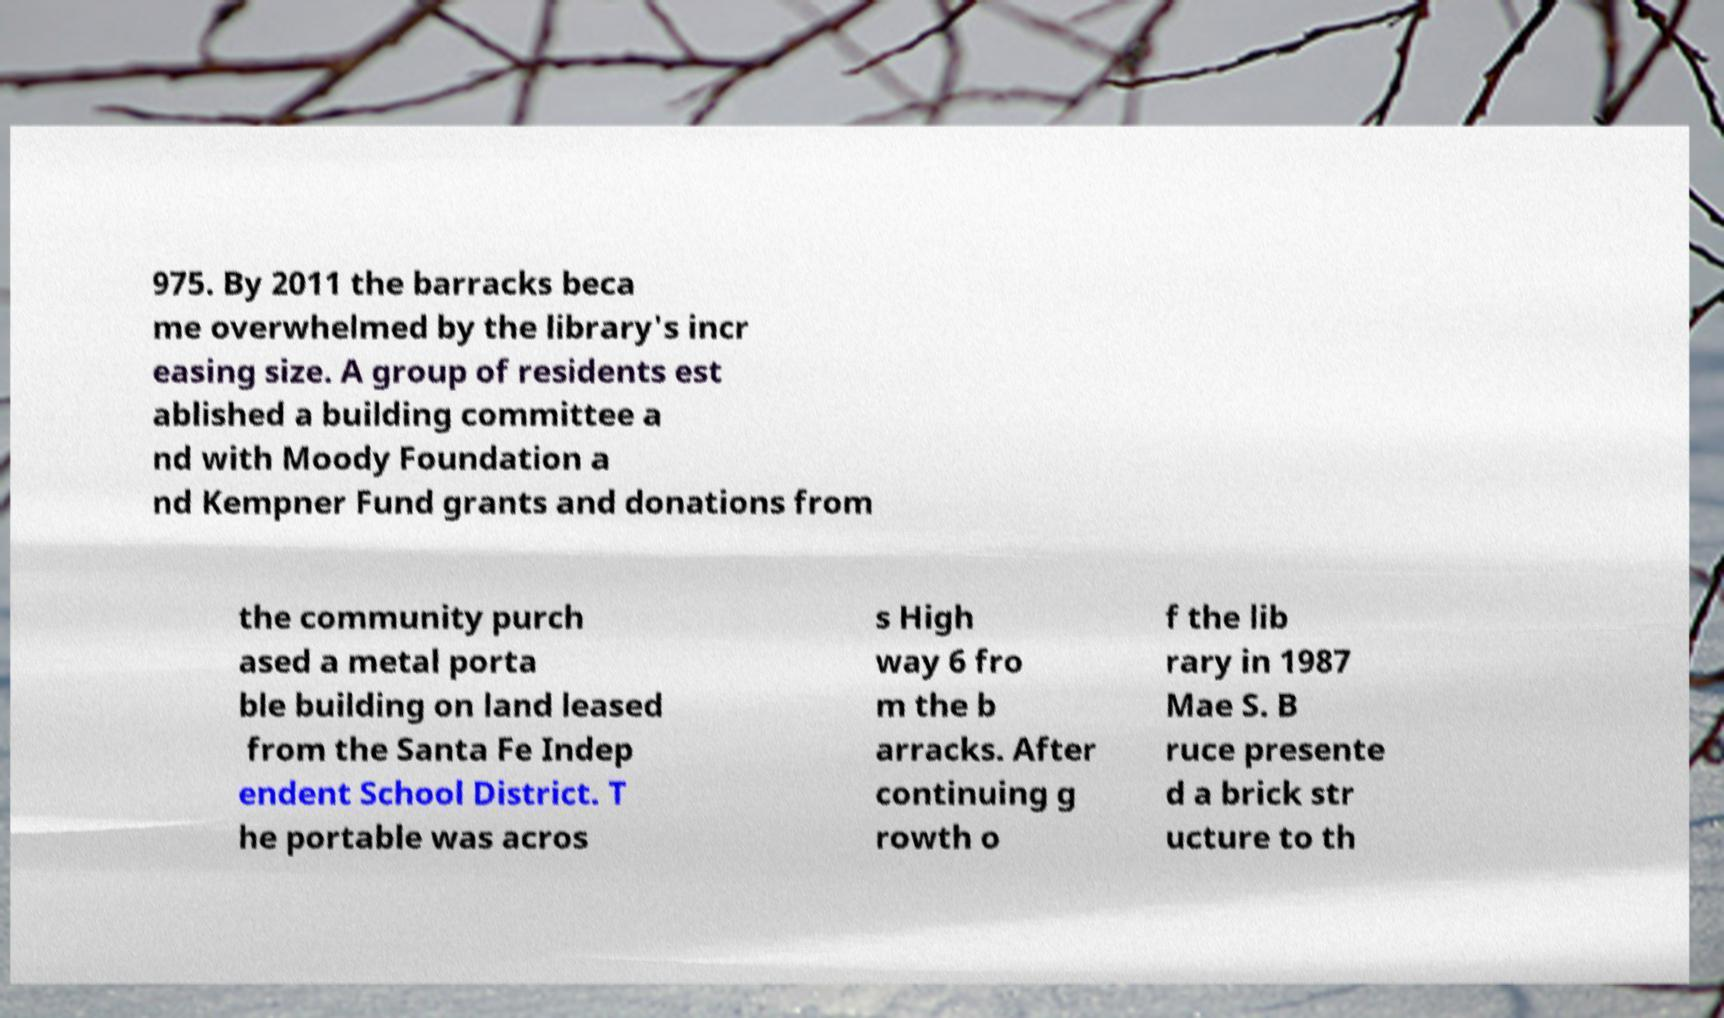There's text embedded in this image that I need extracted. Can you transcribe it verbatim? 975. By 2011 the barracks beca me overwhelmed by the library's incr easing size. A group of residents est ablished a building committee a nd with Moody Foundation a nd Kempner Fund grants and donations from the community purch ased a metal porta ble building on land leased from the Santa Fe Indep endent School District. T he portable was acros s High way 6 fro m the b arracks. After continuing g rowth o f the lib rary in 1987 Mae S. B ruce presente d a brick str ucture to th 